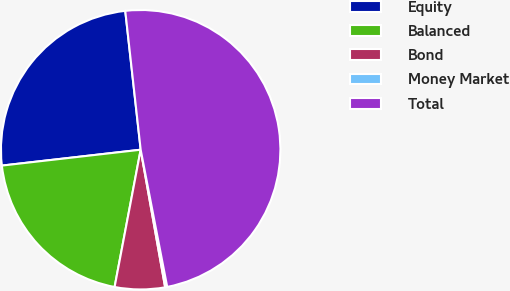<chart> <loc_0><loc_0><loc_500><loc_500><pie_chart><fcel>Equity<fcel>Balanced<fcel>Bond<fcel>Money Market<fcel>Total<nl><fcel>25.05%<fcel>20.2%<fcel>5.79%<fcel>0.24%<fcel>48.72%<nl></chart> 